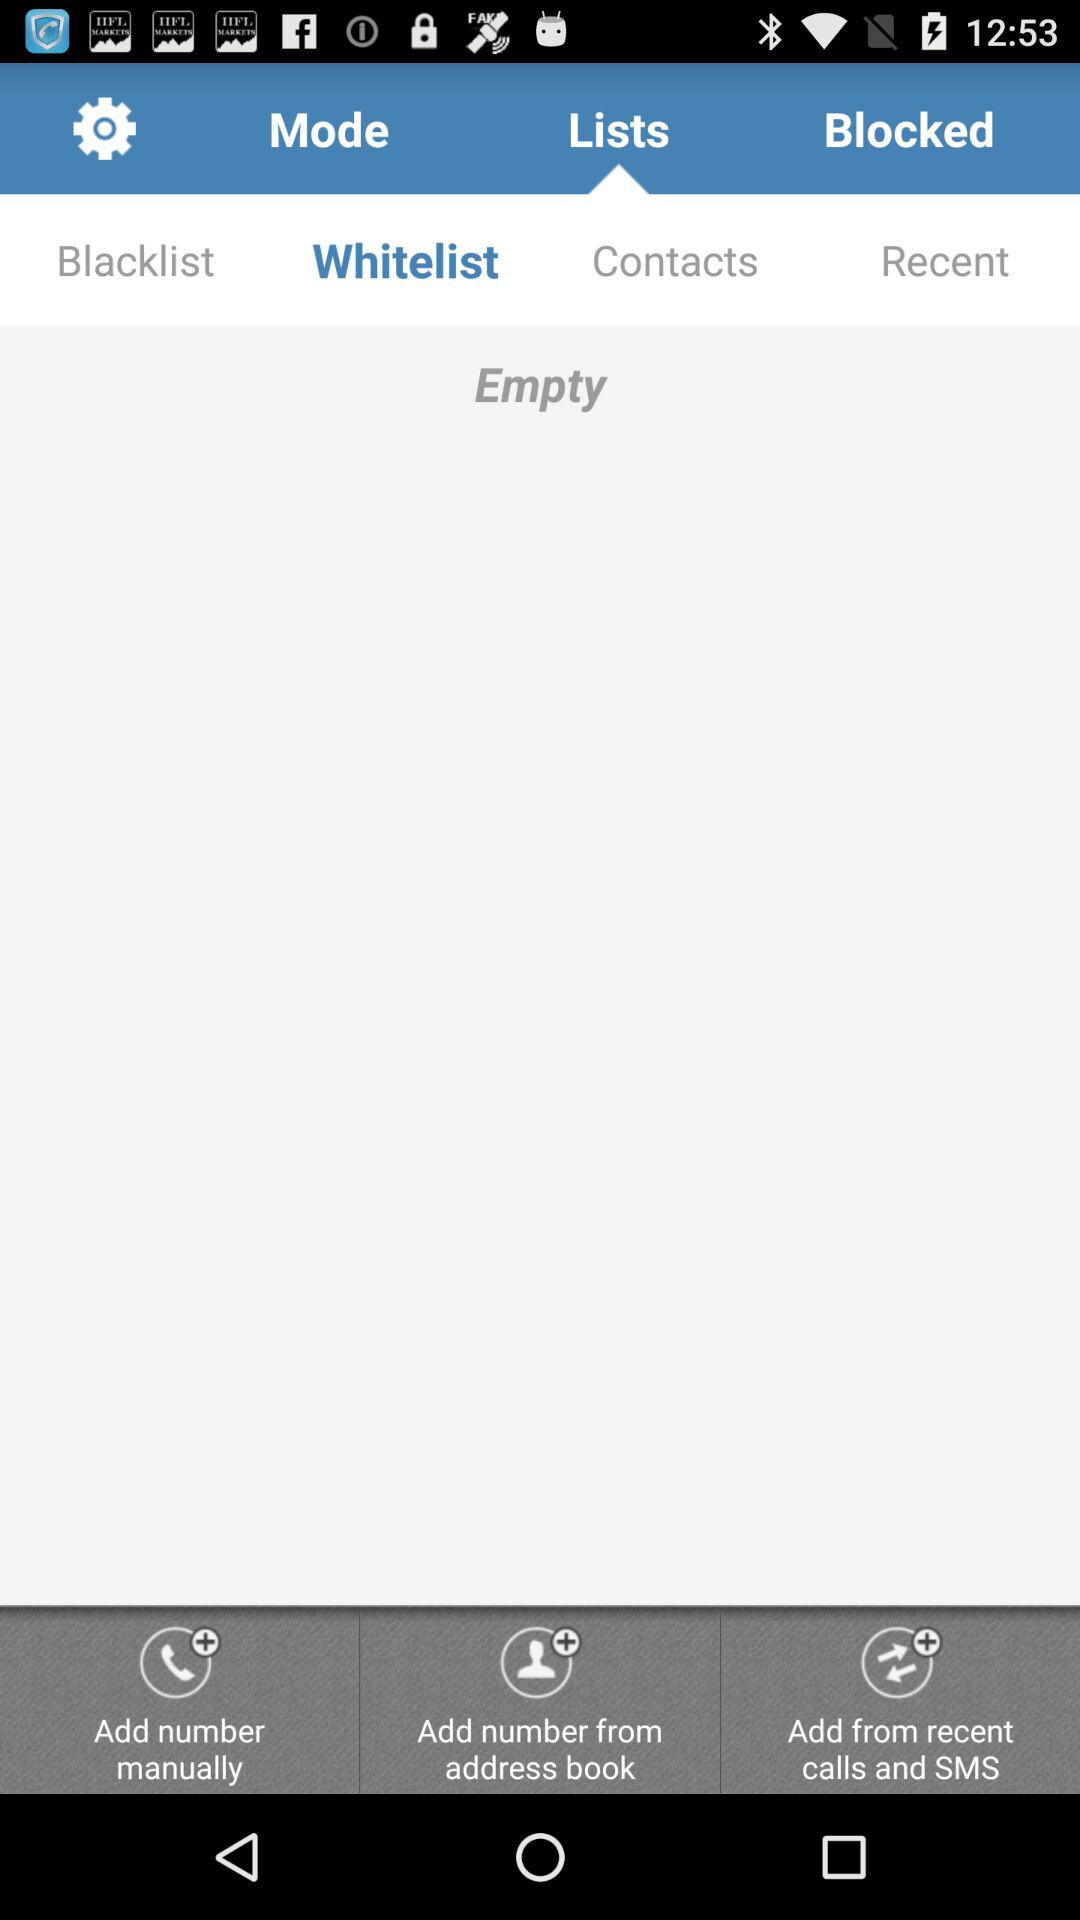Which tab is selected? The selected tabs are "Lists" and "Whitelist". 